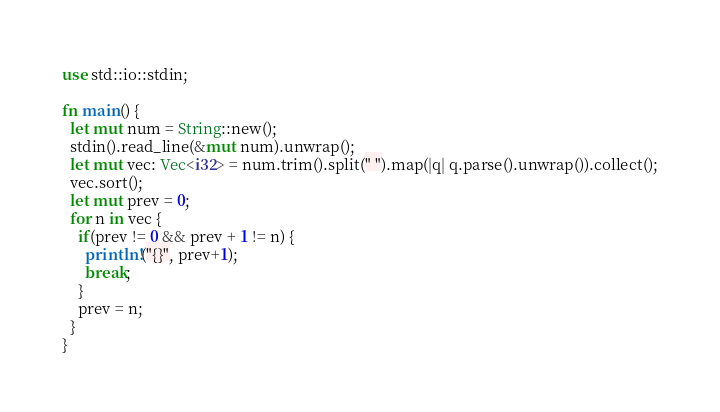Convert code to text. <code><loc_0><loc_0><loc_500><loc_500><_Rust_>use std::io::stdin;

fn main() {
  let mut num = String::new();
  stdin().read_line(&mut num).unwrap();
  let mut vec: Vec<i32> = num.trim().split(" ").map(|q| q.parse().unwrap()).collect();
  vec.sort();
  let mut prev = 0;
  for n in vec {
    if(prev != 0 && prev + 1 != n) {
	  println!("{}", prev+1);
      break;
    }
    prev = n; 
  } 
}</code> 